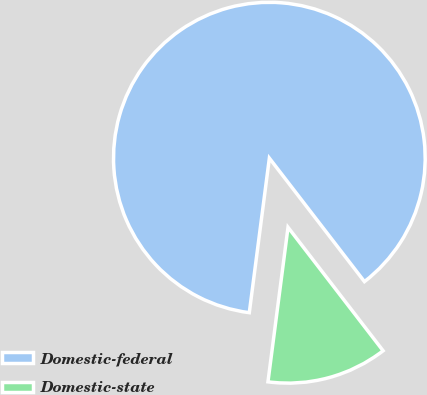Convert chart to OTSL. <chart><loc_0><loc_0><loc_500><loc_500><pie_chart><fcel>Domestic-federal<fcel>Domestic-state<nl><fcel>87.5%<fcel>12.5%<nl></chart> 